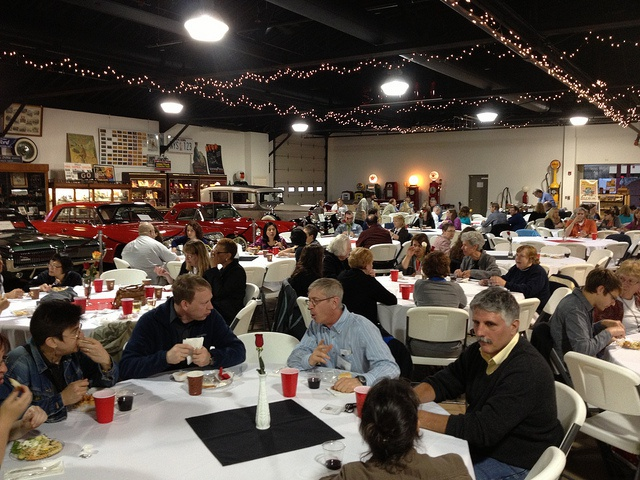Describe the objects in this image and their specific colors. I can see dining table in black, lightgray, and darkgray tones, people in black, gray, and maroon tones, people in black, gray, and maroon tones, people in black, gray, maroon, and brown tones, and people in black, gray, brown, and maroon tones in this image. 